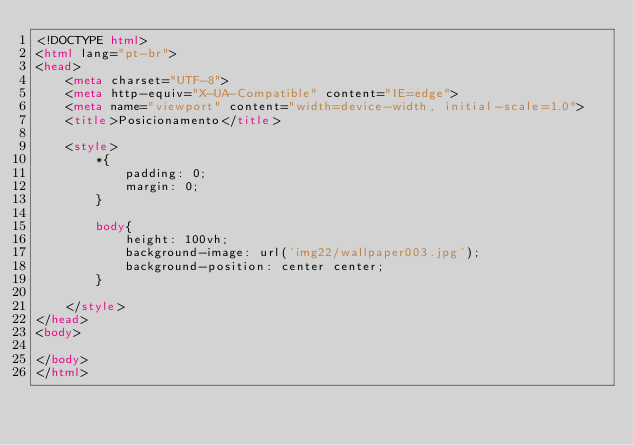<code> <loc_0><loc_0><loc_500><loc_500><_HTML_><!DOCTYPE html>
<html lang="pt-br">
<head>
    <meta charset="UTF-8">
    <meta http-equiv="X-UA-Compatible" content="IE=edge">
    <meta name="viewport" content="width=device-width, initial-scale=1.0">
    <title>Posicionamento</title>

    <style>
        *{
            padding: 0;
            margin: 0;
        }

        body{
            height: 100vh;
            background-image: url('img22/wallpaper003.jpg');
            background-position: center center;
        }

    </style>
</head>
<body>
    
</body>
</html></code> 